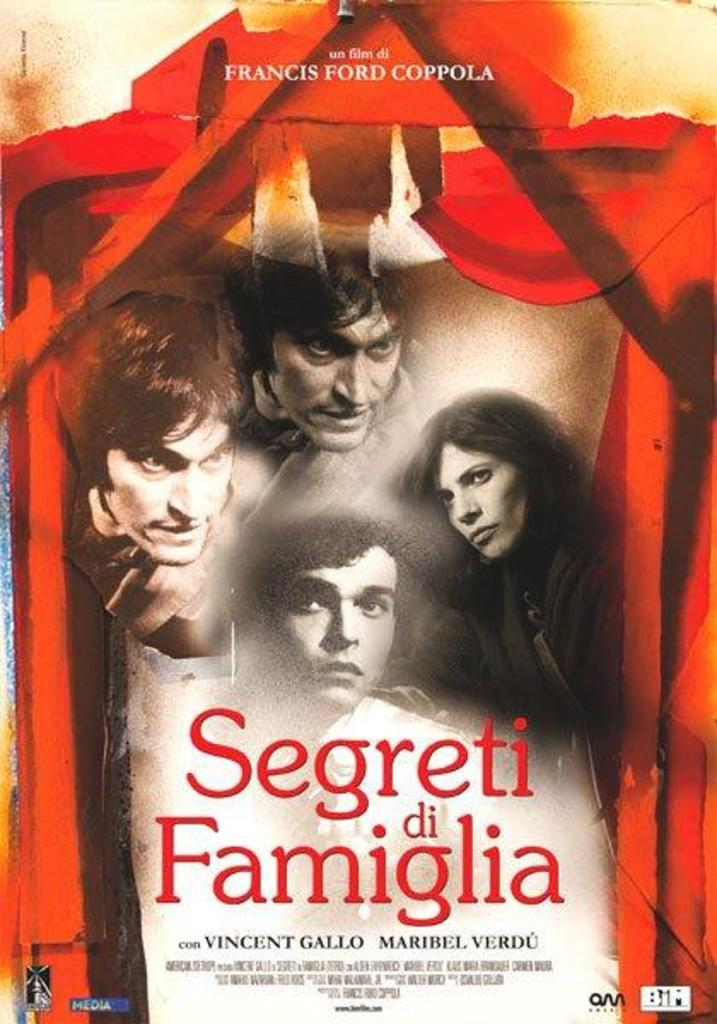<image>
Create a compact narrative representing the image presented. a film by fances ford coppola called Segreti de Familia has a red border 